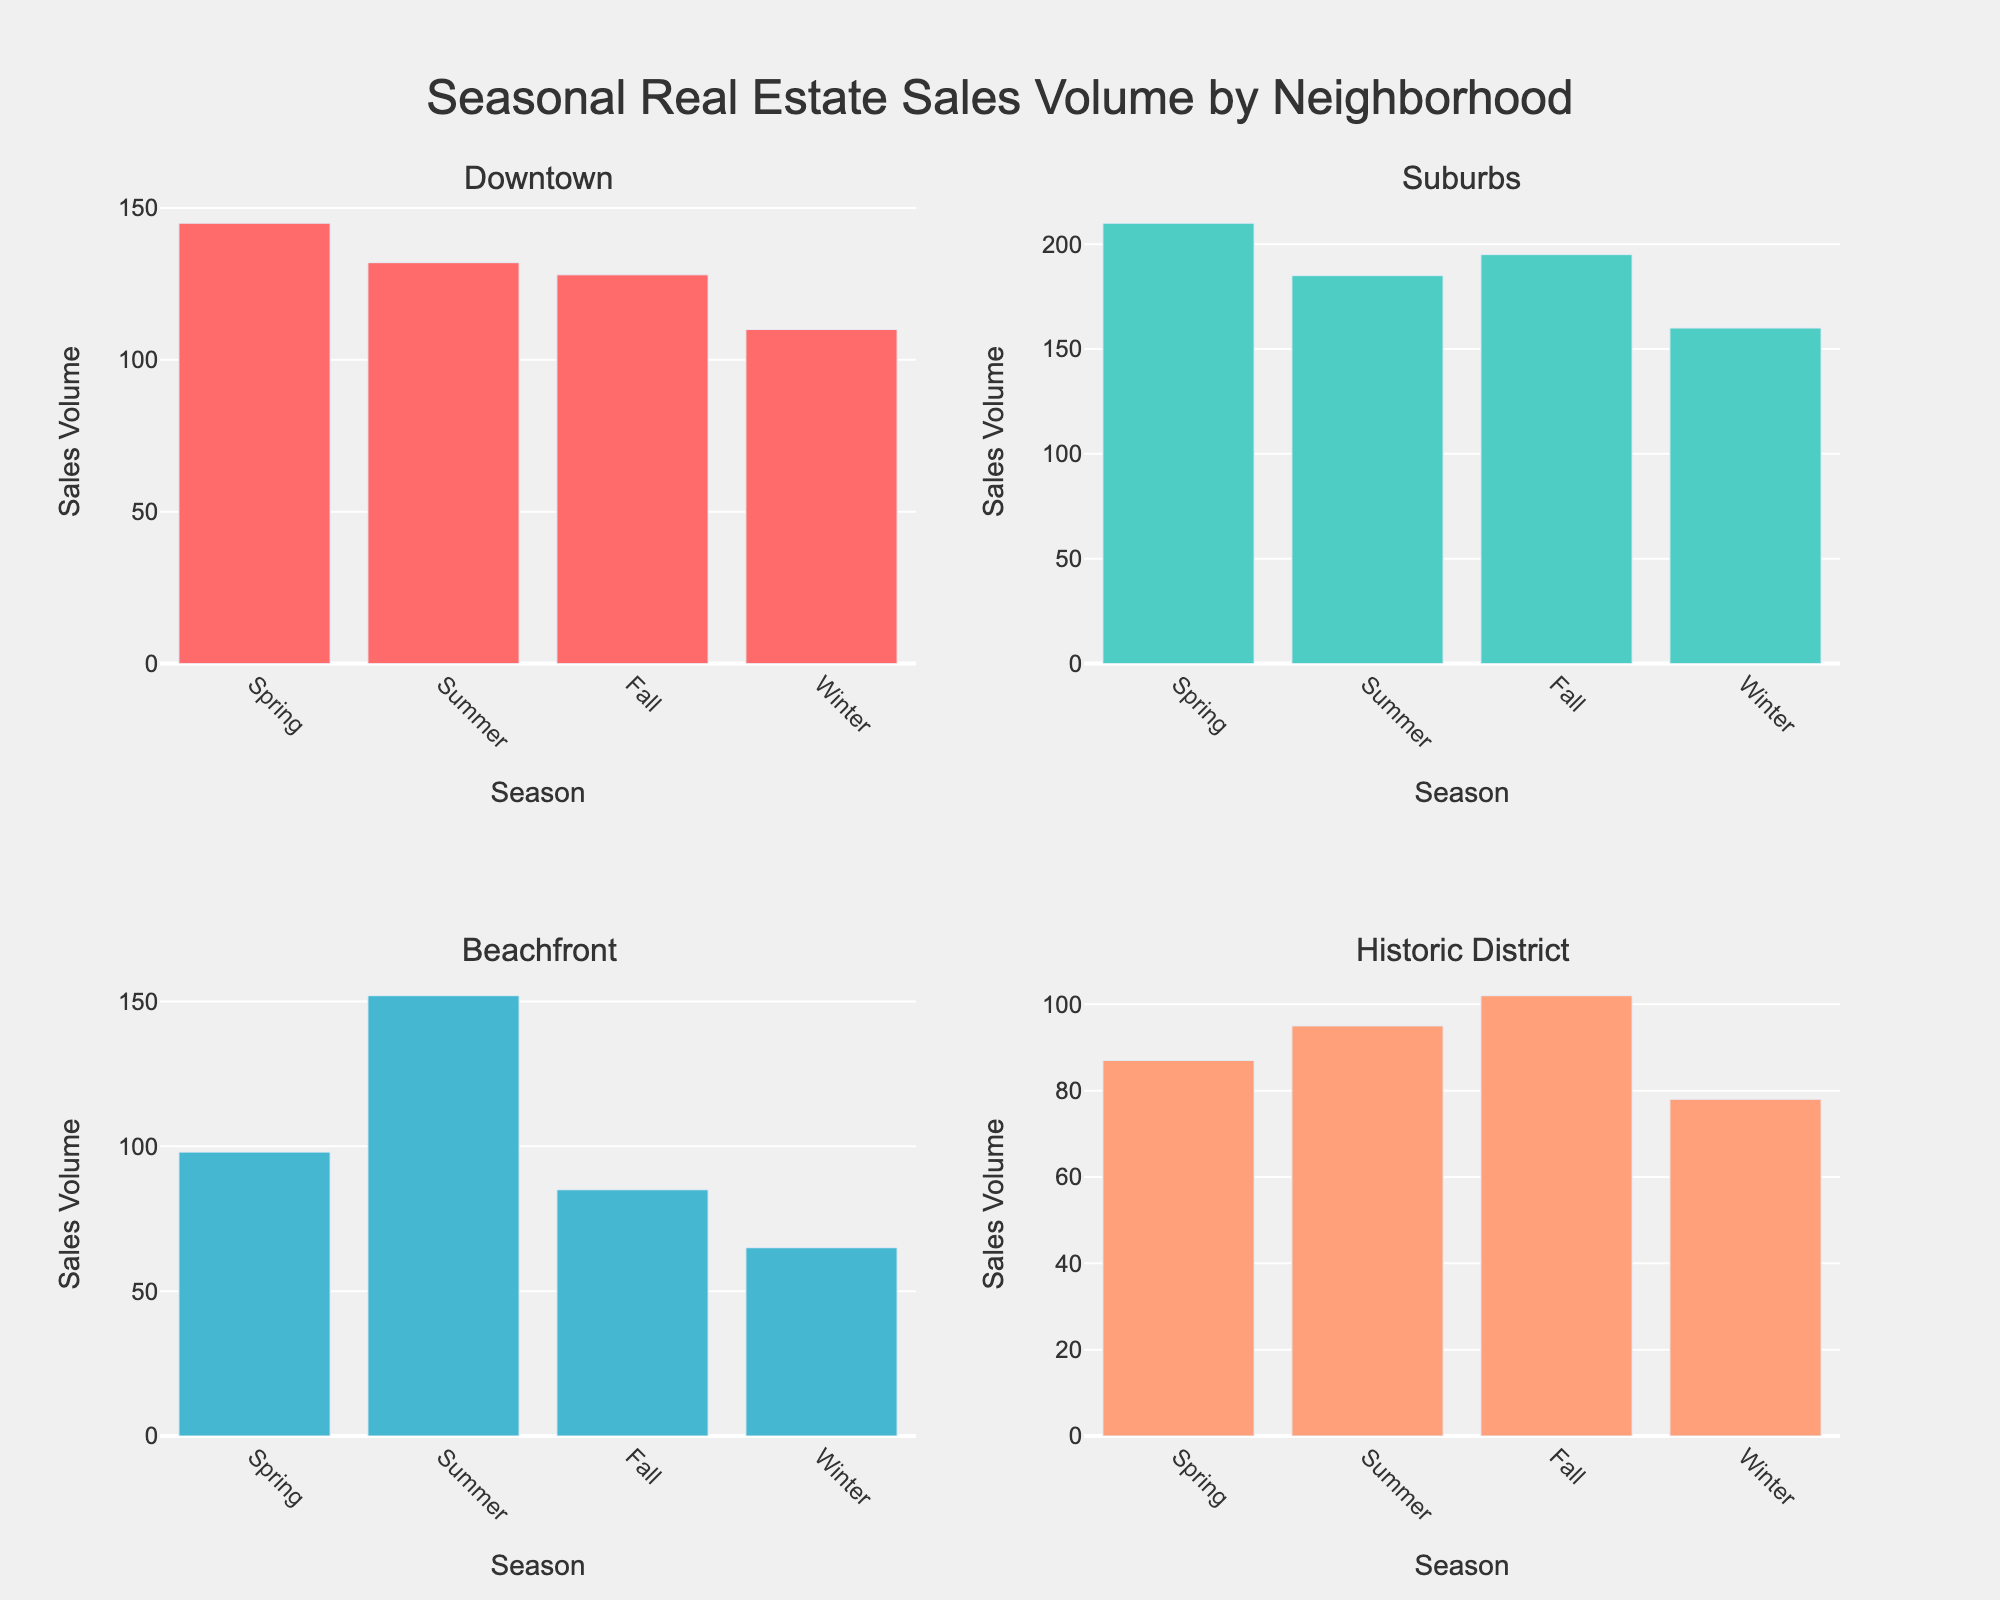What's the title of the figure? The title is usually positioned at the top and is larger and bolder than other text in the figure. Here it's clearly labeled as "Seasonal Real Estate Sales Volume by Neighborhood".
Answer: Seasonal Real Estate Sales Volume by Neighborhood Which neighborhood has the highest sales volume in Summer? By looking at the Summer category in each subplot, the Beachfront neighborhood shows the highest sales volume bar.
Answer: Beachfront What season has the lowest sales volume across all neighborhoods? By examining the bar heights for each season across all subplots, Winter consistently shows the shortest bars indicating the lowest sales volumes.
Answer: Winter What's the difference in Spring sales volume between Downtown and Suburbs neighborhoods? Locate the Spring bars in both the Downtown and Suburbs subplots. Downtown's sales volume is 145, and Suburbs' is 210. The difference is 210 - 145.
Answer: 65 In which season does the Historic District have the highest sales volume? Check the heights of each bar in the Historic District subplot. The highest bar is in the Fall.
Answer: Fall Compare the sales volumes of the Beachfront neighborhood in Spring and Winter. Which season has higher sales volume? Beachfront's sales volume in Spring is 98 and in Winter is 65. Comparing these, Spring has a higher sales volume.
Answer: Spring What is the average sales volume of the Suburbs neighborhood across all seasons? Add the sales volumes for Spring, Summer, Fall, and Winter in the Suburbs subplot: 210 + 185 + 195 + 160 = 750. Then, divide by the number of seasons (4).
Answer: 187.5 During which season do Downtown and Historic District neighborhoods have equal sales volumes? Compare the bar heights for Downtown and Historic District across all seasons. In Summer, both Downtown and Historic District have approximately equal sales volumes (132 and 95 respectively—they are not equal, so no season is applicable). Therefore, none match.
Answer: None How much higher is the sales volume for the Beachfront neighborhood in Summer compared to Fall? Beachfront's Summer sales volume is 152 and Fall is 85. The difference is 152 - 85.
Answer: 67 Which neighborhood shows the most significant decrease in sales volume from Fall to Winter? By examining the Fall and Winter bar heights in each subplot, the Beachfront neighborhood shows the largest drop from 85 to 65.
Answer: Beachfront 